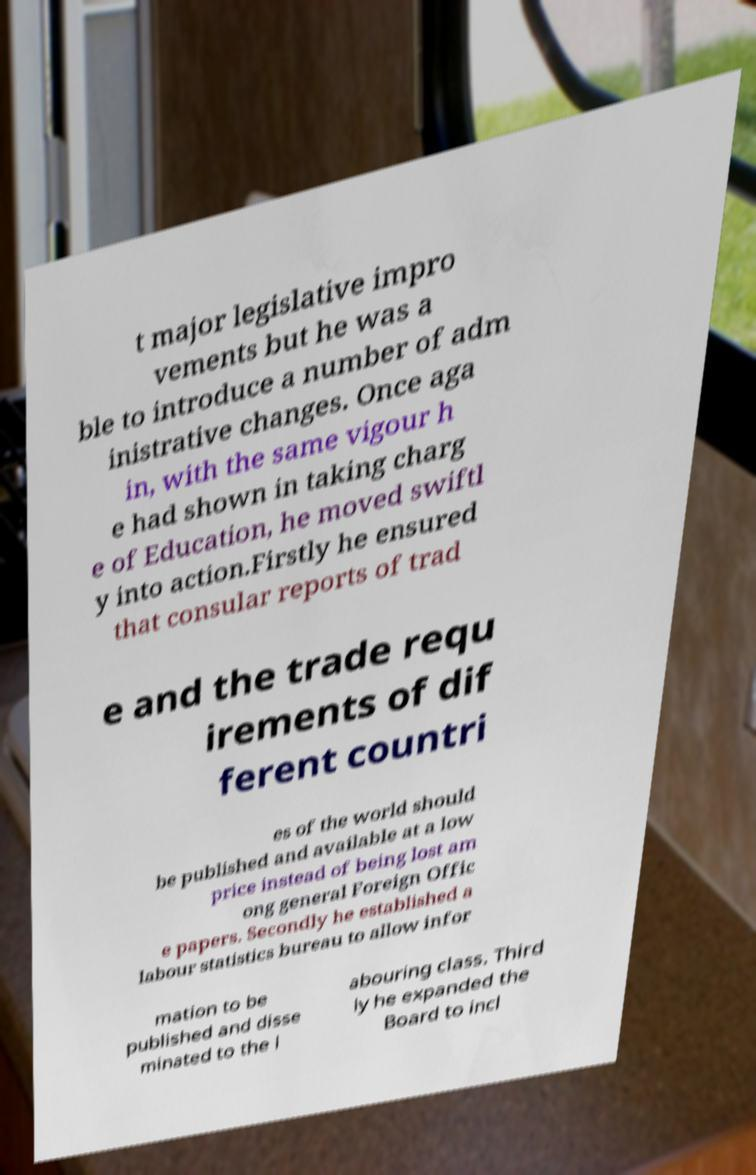Please identify and transcribe the text found in this image. t major legislative impro vements but he was a ble to introduce a number of adm inistrative changes. Once aga in, with the same vigour h e had shown in taking charg e of Education, he moved swiftl y into action.Firstly he ensured that consular reports of trad e and the trade requ irements of dif ferent countri es of the world should be published and available at a low price instead of being lost am ong general Foreign Offic e papers. Secondly he established a labour statistics bureau to allow infor mation to be published and disse minated to the l abouring class. Third ly he expanded the Board to incl 